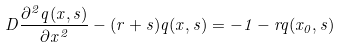Convert formula to latex. <formula><loc_0><loc_0><loc_500><loc_500>D \frac { \partial ^ { 2 } q ( x , s ) } { \partial x ^ { 2 } } - ( r + s ) q ( x , s ) = - 1 - r q ( x _ { 0 } , s )</formula> 